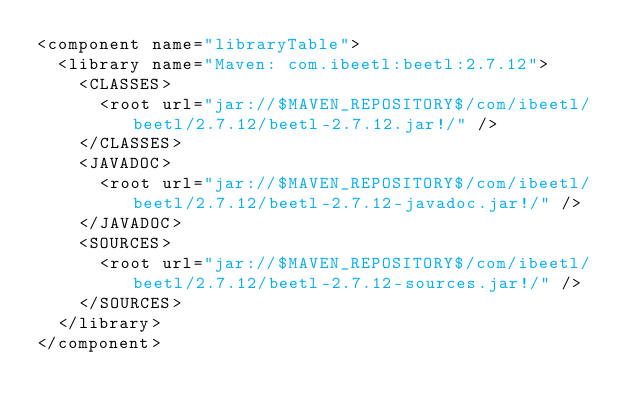<code> <loc_0><loc_0><loc_500><loc_500><_XML_><component name="libraryTable">
  <library name="Maven: com.ibeetl:beetl:2.7.12">
    <CLASSES>
      <root url="jar://$MAVEN_REPOSITORY$/com/ibeetl/beetl/2.7.12/beetl-2.7.12.jar!/" />
    </CLASSES>
    <JAVADOC>
      <root url="jar://$MAVEN_REPOSITORY$/com/ibeetl/beetl/2.7.12/beetl-2.7.12-javadoc.jar!/" />
    </JAVADOC>
    <SOURCES>
      <root url="jar://$MAVEN_REPOSITORY$/com/ibeetl/beetl/2.7.12/beetl-2.7.12-sources.jar!/" />
    </SOURCES>
  </library>
</component></code> 